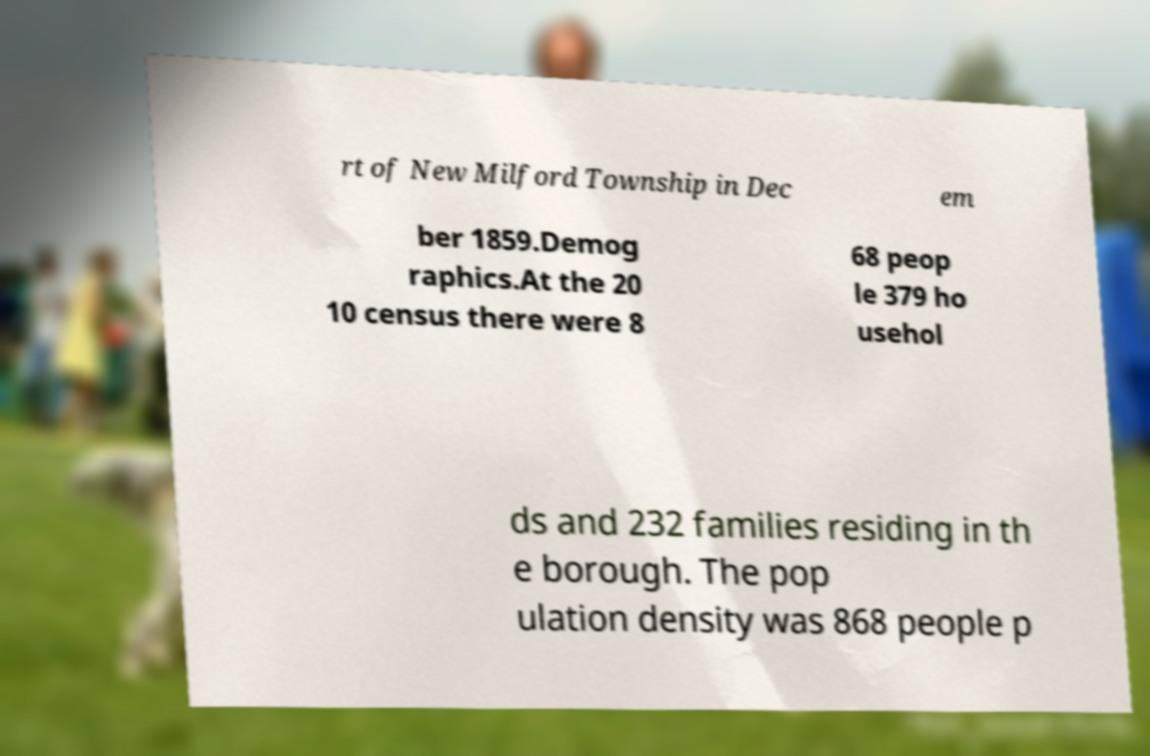Could you assist in decoding the text presented in this image and type it out clearly? rt of New Milford Township in Dec em ber 1859.Demog raphics.At the 20 10 census there were 8 68 peop le 379 ho usehol ds and 232 families residing in th e borough. The pop ulation density was 868 people p 